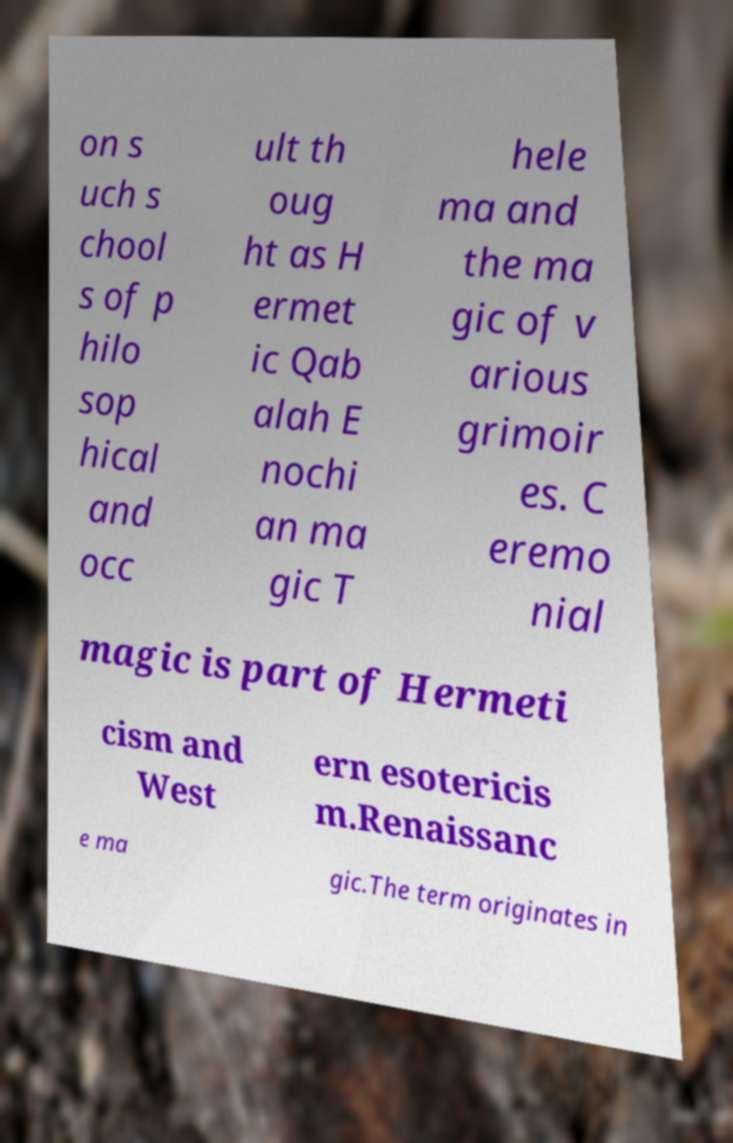I need the written content from this picture converted into text. Can you do that? on s uch s chool s of p hilo sop hical and occ ult th oug ht as H ermet ic Qab alah E nochi an ma gic T hele ma and the ma gic of v arious grimoir es. C eremo nial magic is part of Hermeti cism and West ern esotericis m.Renaissanc e ma gic.The term originates in 